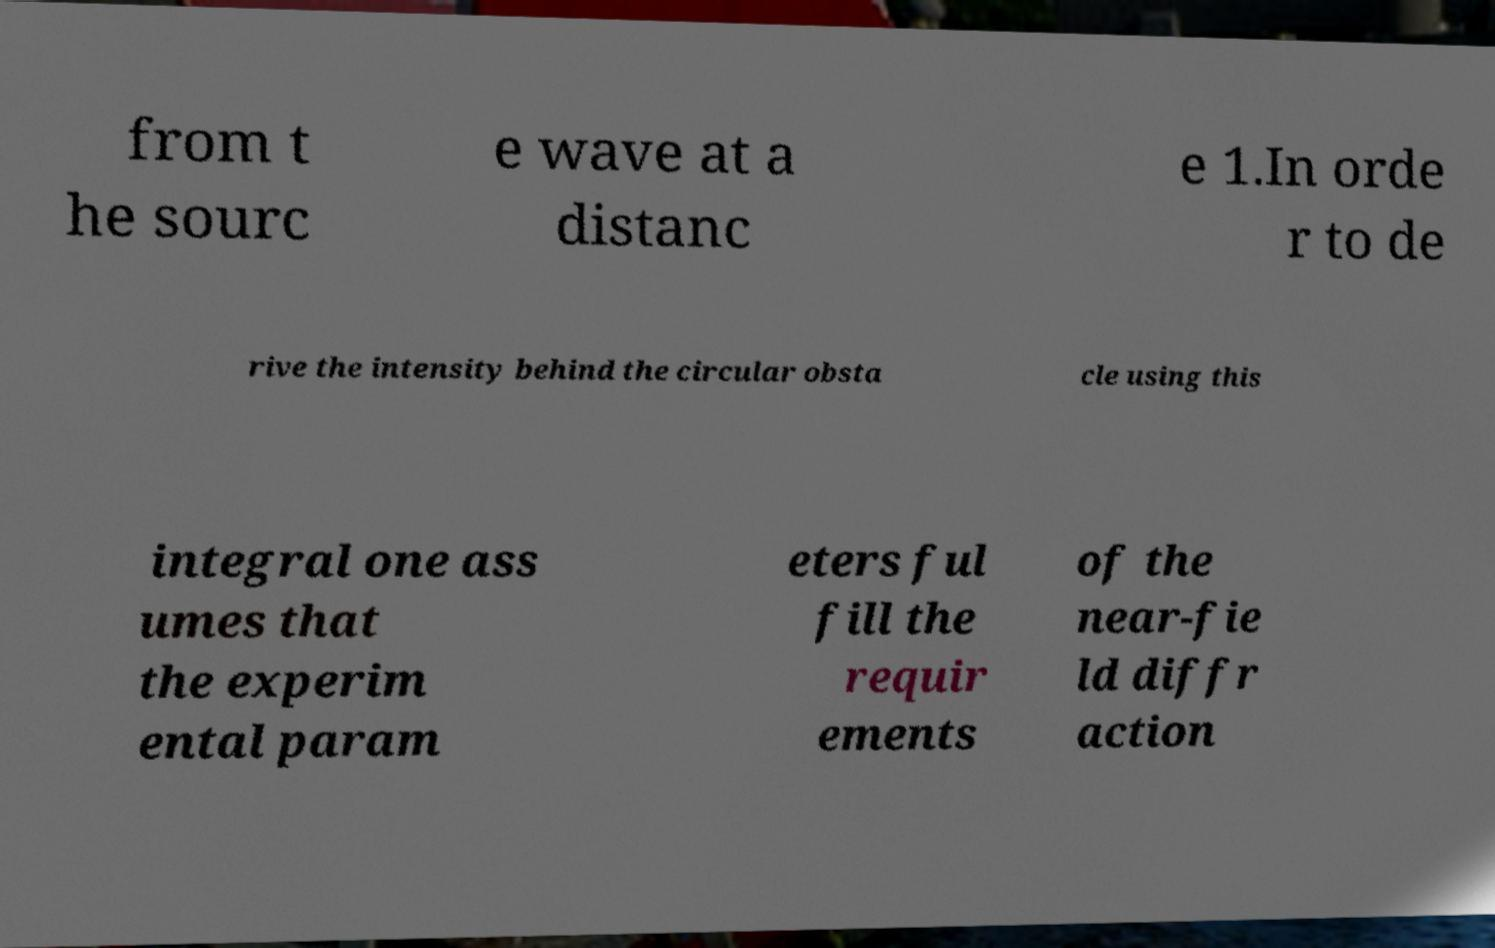Can you accurately transcribe the text from the provided image for me? from t he sourc e wave at a distanc e 1.In orde r to de rive the intensity behind the circular obsta cle using this integral one ass umes that the experim ental param eters ful fill the requir ements of the near-fie ld diffr action 